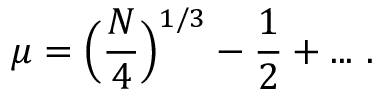<formula> <loc_0><loc_0><loc_500><loc_500>\mu = \left ( \frac { N } { 4 } \right ) ^ { 1 / 3 } - \frac { 1 } { 2 } + \dots .</formula> 